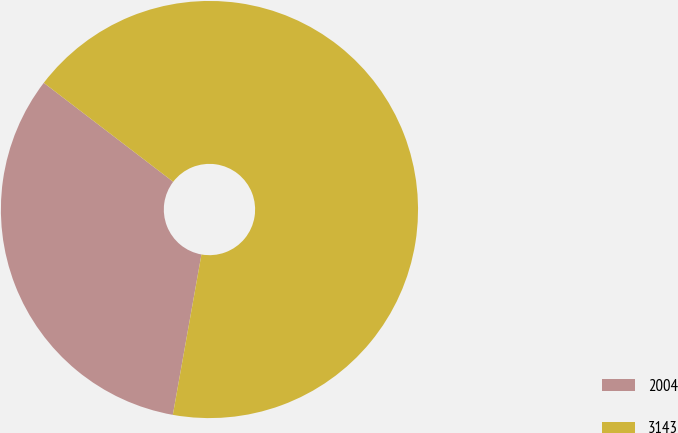<chart> <loc_0><loc_0><loc_500><loc_500><pie_chart><fcel>2004<fcel>3143<nl><fcel>32.58%<fcel>67.42%<nl></chart> 